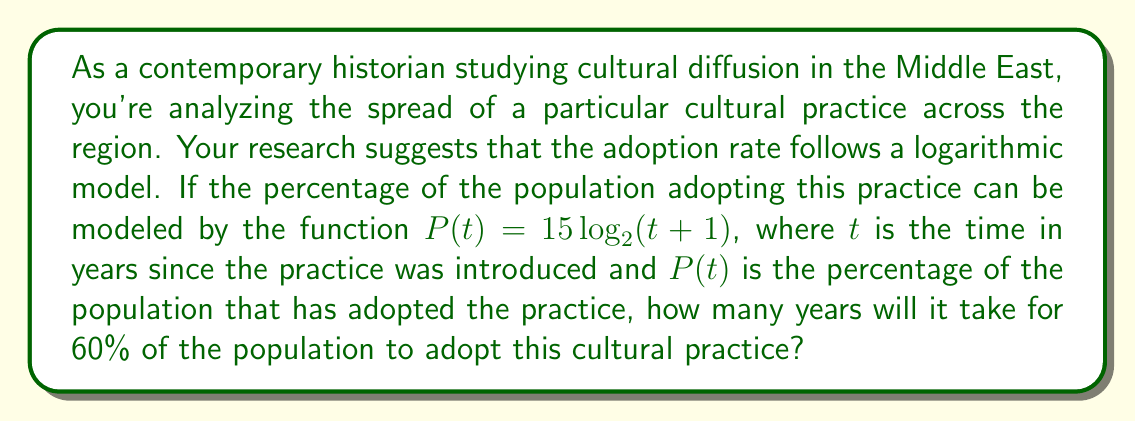Show me your answer to this math problem. To solve this problem, we need to use the given logarithmic model and solve for $t$ when $P(t) = 60$. Let's approach this step-by-step:

1) We start with the equation:
   $P(t) = 15 \log_2(t + 1)$

2) We want to find $t$ when $P(t) = 60$, so we substitute this:
   $60 = 15 \log_2(t + 1)$

3) Divide both sides by 15:
   $4 = \log_2(t + 1)$

4) To solve for $t$, we need to apply the inverse function of $\log_2$, which is $2^x$:
   $2^4 = t + 1$

5) Simplify the left side:
   $16 = t + 1$

6) Subtract 1 from both sides to isolate $t$:
   $15 = t$

This result shows that it will take 15 years for 60% of the population to adopt this cultural practice.

This logarithmic model is particularly relevant for cultural diffusion studies in the Middle East, as it captures the often observed pattern of rapid initial adoption followed by a slower rate of change as the practice becomes more widespread. This social approach to understanding cultural changes provides valuable insights into the dynamics of societal transformations in the region.
Answer: 15 years 